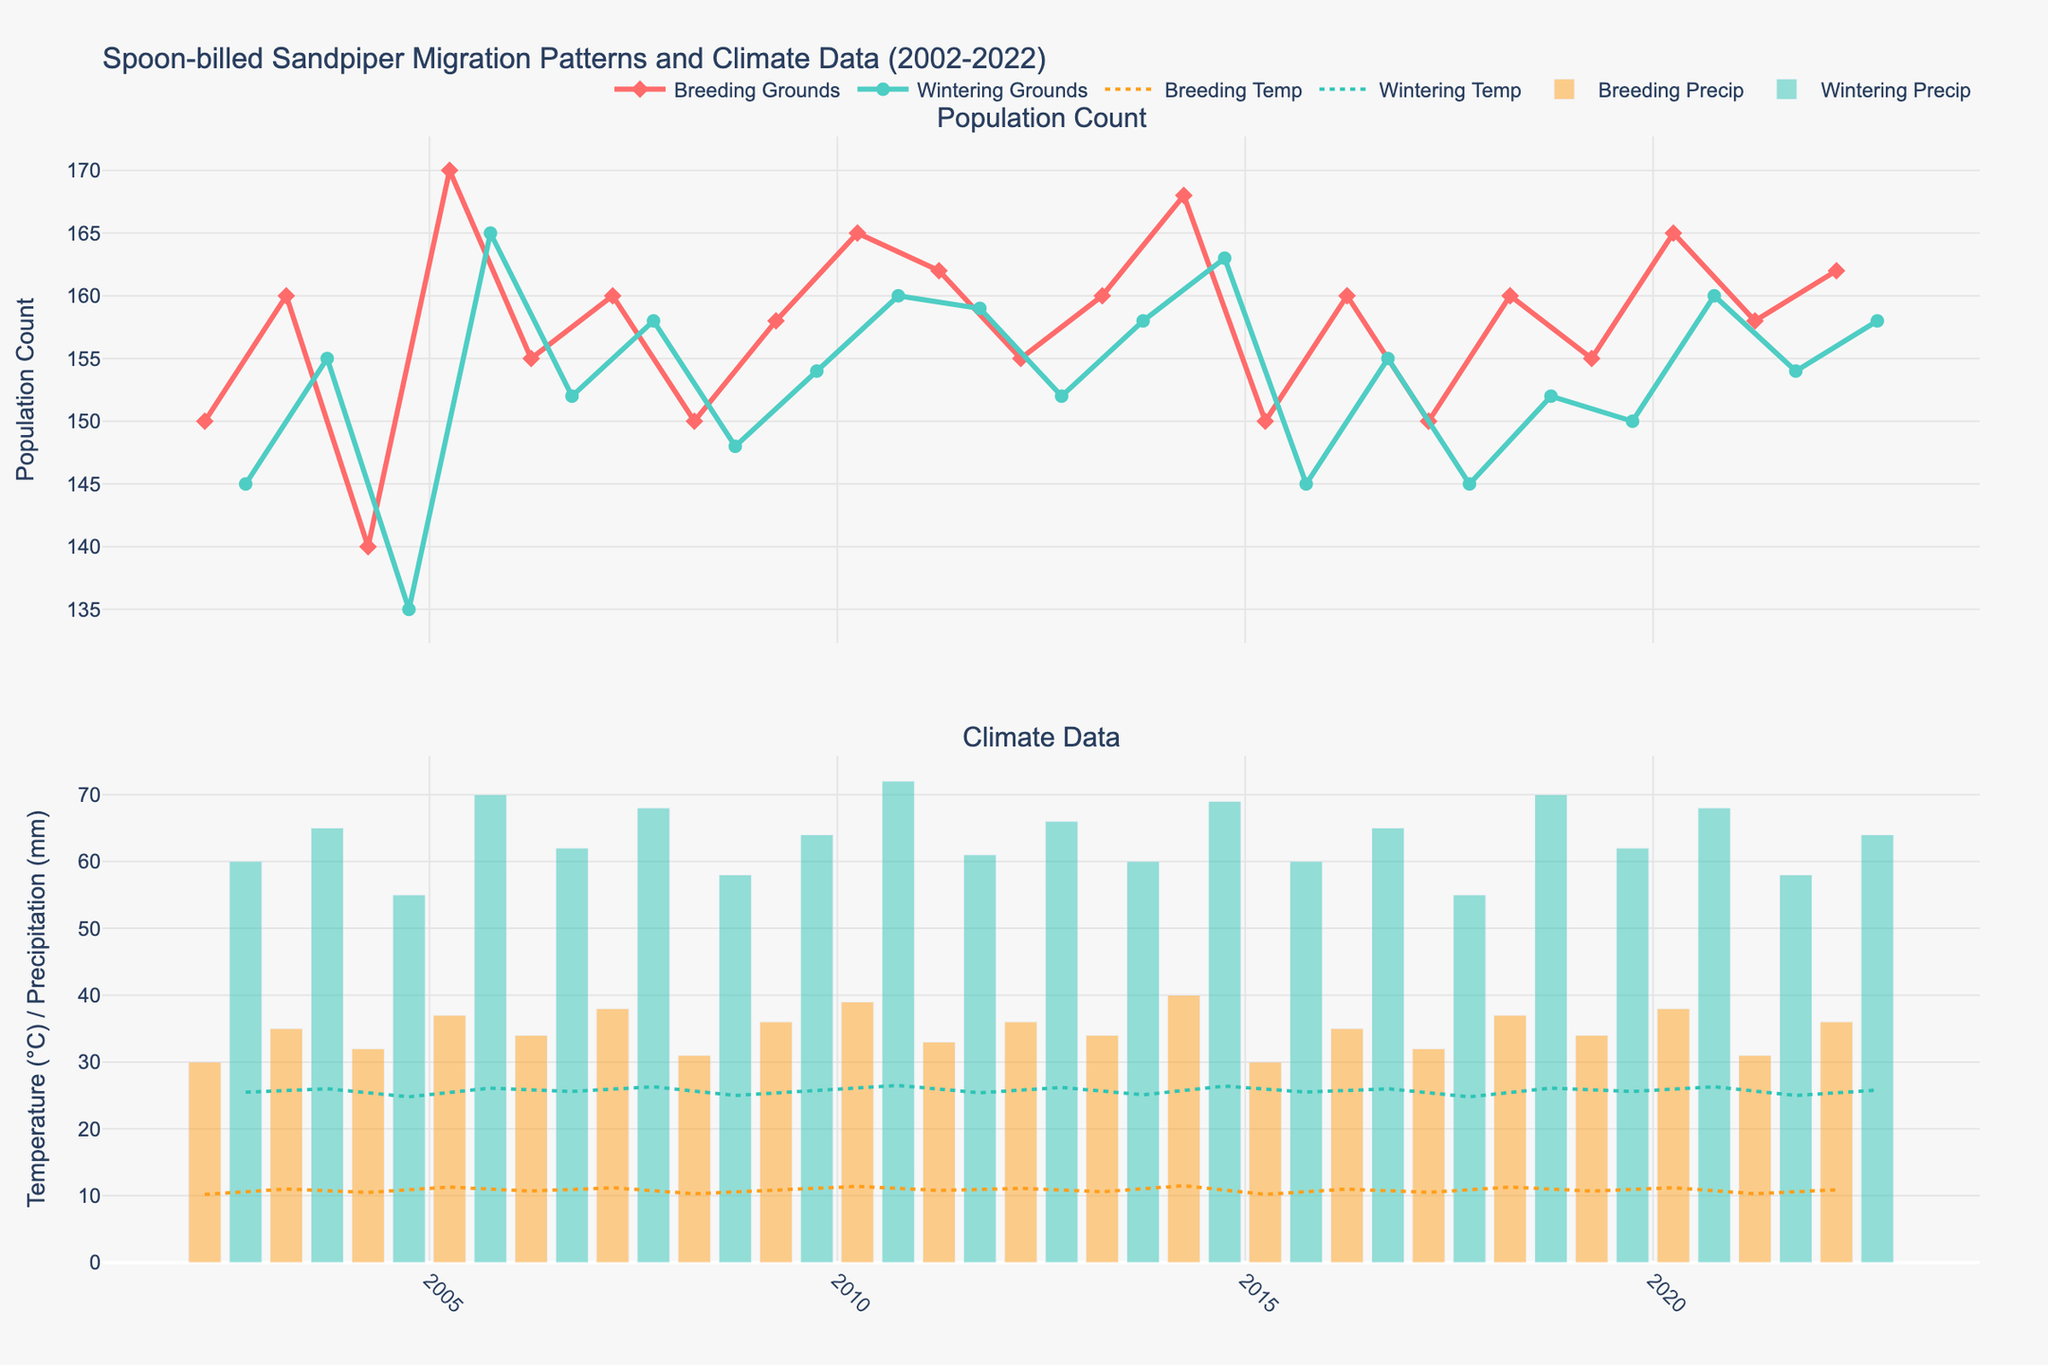What is the title of the figure? The title of the figure is at the top of the plot and provides a summary of what the plot shows.
Answer: Spoon-billed Sandpiper Migration Patterns and Climate Data (2002-2022) How many total data points are plotted for Breeding Grounds' population count? Count the number of markers for the Breeding Grounds population in the upper subplot. Each marker represents one data point.
Answer: 21 Which location shows a higher average temperature in April 2013? Compare the Breeding Temp and Wintering Temp lines at the April 2013 time point in the lower subplot. The Breeding Grounds has higher temperature since 10.6°C > 25.1°C.
Answer: Wintering Grounds What is the trend in Spoon-billed Sandpiper population count in the Breeding Grounds from 2002 to 2022? Observe the trend line in the upper subplot for Breeding Grounds from the first to the last year. Although there are some fluctuations, overall, the population shows a gradual increase.
Answer: Gradually increasing In which month does precipitation appear higher, April or October? Compare the bars for April and October along the x-axis in both subplots. October has consistently higher bar heights for precipitation compared to April.
Answer: October How does the temperature in Wintering Grounds correlate with the population count of Spoon-billed Sandpiper? Look at the lower subplot's temperature line for Wintering Grounds, compare temperature peaks and troughs with the upper subplot's population line for Wintering Grounds. Higher temperatures tend to correspond with higher populations.
Answer: Higher temperature correlates with higher population in Wintering Grounds What was the highest population count recorded for the Spoon-billed Sandpiper, and in which location did it occur? Identify the maximum y-value and observe the data point in the upper subplot to determine whether it is for Breeding or Wintering Grounds. The highest count is 170 in 2005 which occurred at Breeding Grounds.
Answer: 170 in Breeding Grounds Which month saw less variability in Spoon-billed Sandpiper population counts, April or October? Compare the variability (fluctuations) of data points in the upper subplot for April and October. April shows more fluctuations compared to October.
Answer: October Between 2002 and 2022, in which year did April record the lowest Spoon-billed Sandpiper population count in Breeding Grounds? Locate the lowest point on the April section of the upper subplot for Breeding Grounds and read off the corresponding year. The lowest count in April is in 2017, with a population of 150.
Answer: 2017 On average, which month had higher average temperatures, April or October? Compare the average level of temperature lines for both months in the second subplot. October lines are generally higher than those for April.
Answer: October 